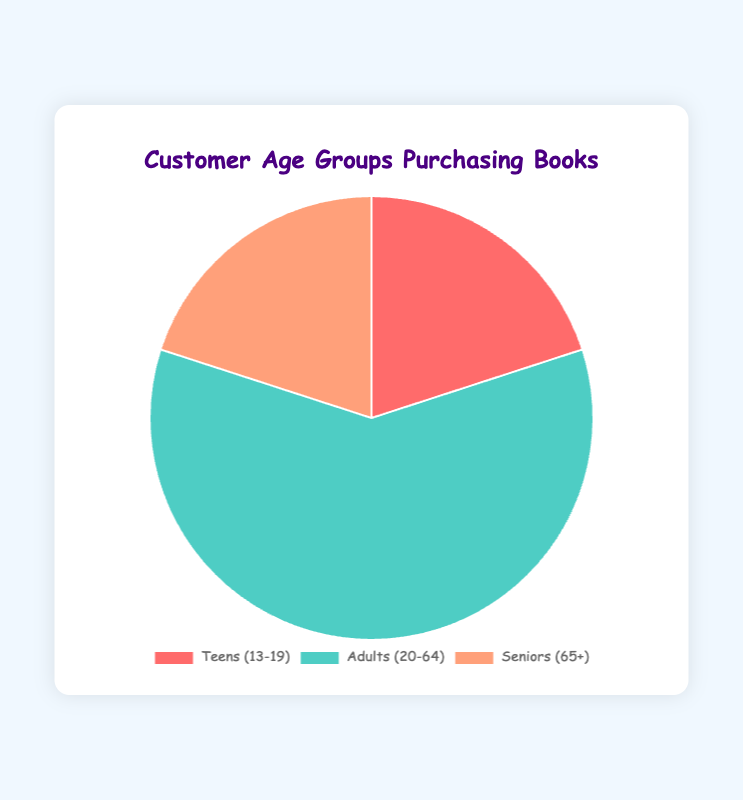What percentage of book purchasers are either Teens or Seniors? Sum the percentages of Teens and Seniors: 20% (Teens) + 20% (Seniors) = 40%
Answer: 40% Which age group constitutes 60% of the book purchasers? The Adults (20-64) group is shown to have 60% in the pie chart.
Answer: Adults (20-64) Are there more Teen customers or Senior customers? Both Teens and Seniors each represent 20% of the total customer base, so they are equal.
Answer: Equal What is the combined percentage of book purchasers that are either Adults or Teens? Sum the percentages of Adults and Teens: 60% (Adults) + 20% (Teens) = 80%
Answer: 80% Which age group has the smallest percentage of book purchasers? Both Teens and Seniors have the smallest percentage of book purchasers at 20% each.
Answer: Teens and Seniors Given that the pie chart labels are colored, what color represents the Adult age group? The Adults (20-64) group is represented by the color green in the pie chart.
Answer: Green By how much do Adults exceed Teens in the percentage of book purchasers? Subtract the Teens' percentage from the Adults' percentage: 60% (Adults) - 20% (Teens) = 40%
Answer: 40% What proportion of the pie chart is represented by Seniors? The Seniors (65+) group represents 20% of the pie chart.
Answer: 20% Which two age groups together make up 40% of the pie chart? The Teens (20%) and the Seniors (20%) combined make up 40% of the pie chart.
Answer: Teens and Seniors 